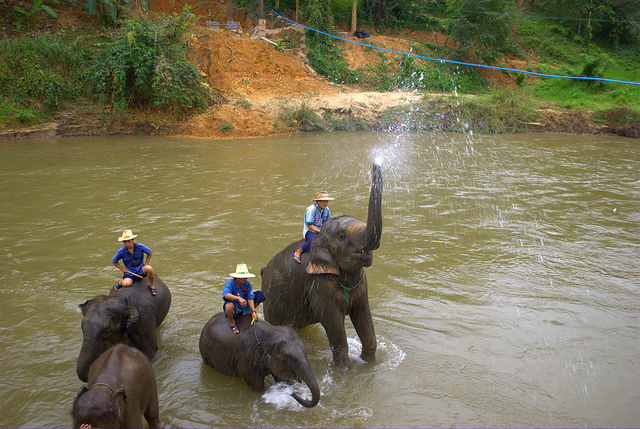<image>What is the purpose of the blue rope? The purpose of the blue rope is unknown. However, it can be used for a zipline or to guide people crossing. What is the purpose of the blue rope? I don't know what the purpose of the blue rope is. It can be used as a zipline, a guideline, or to attach between shores to help people cross the river. 